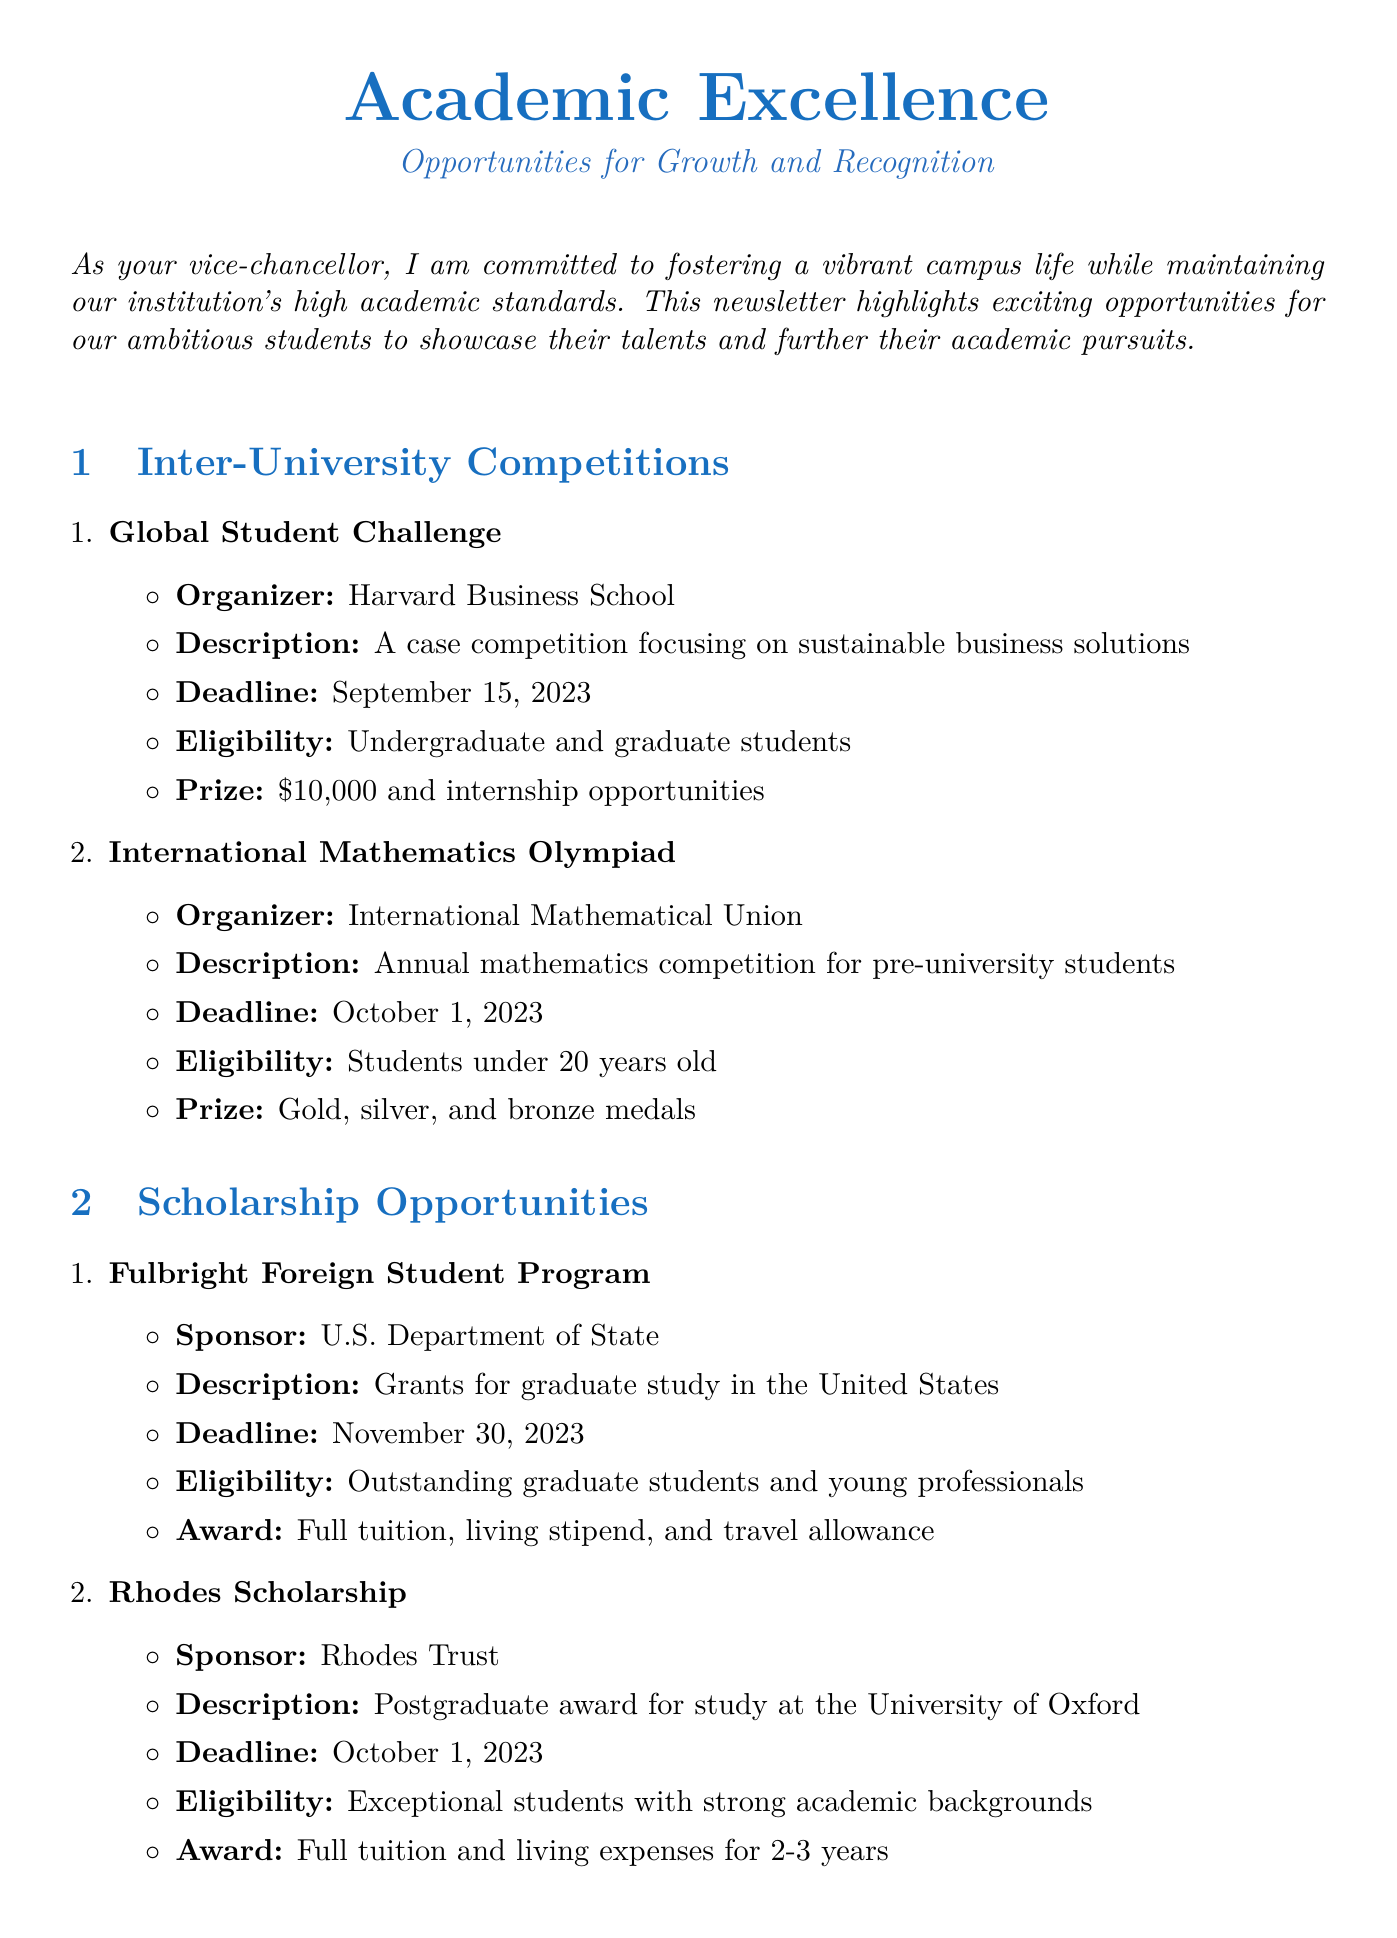what is the title of the newsletter? The title of the newsletter is stated at the top of the document.
Answer: Academic Excellence: Opportunities for Growth and Recognition who organizes the Global Student Challenge? The organizer of the Global Student Challenge is mentioned in the inter-university competitions section.
Answer: Harvard Business School what is the prize for the International Mathematics Olympiad? The prize for the International Mathematics Olympiad is detailed in the competition description.
Answer: Gold, silver, and bronze medals when is the deadline for the Fulbright Foreign Student Program? The deadline for the Fulbright Foreign Student Program is provided in the scholarship opportunities section.
Answer: November 30, 2023 which conference focuses on Artificial Intelligence? The conference that focuses on Artificial Intelligence is listed under academic conferences with its name.
Answer: IEEE International Conference on Artificial Intelligence and Machine Learning how long does the Rhodes Scholarship cover tuition? The duration for which the Rhodes Scholarship covers tuition is specified in the scholarship opportunities section.
Answer: 2-3 years what message does the Vice Chancellor convey? The Vice Chancellor's message about students participating in competitions is summarized at the end of the document.
Answer: Seize these opportunities to challenge themselves academically where is the International Conference on Climate Change Adaptation held? The location for the International Conference on Climate Change Adaptation is provided in the academic conferences section.
Answer: Copenhagen, Denmark 